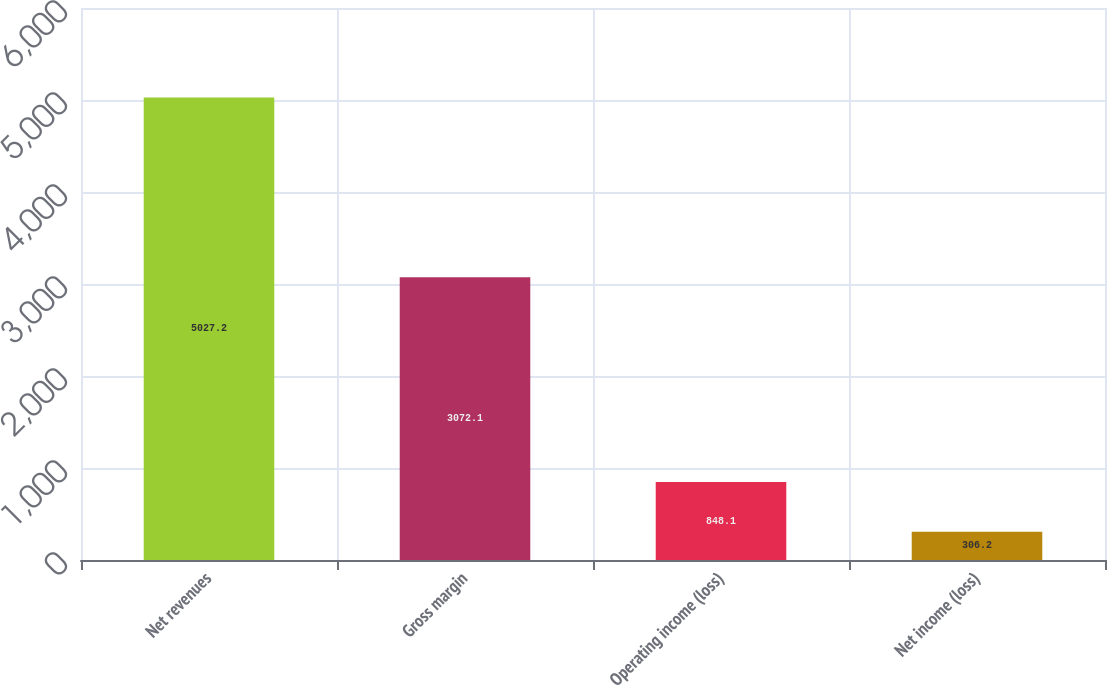Convert chart to OTSL. <chart><loc_0><loc_0><loc_500><loc_500><bar_chart><fcel>Net revenues<fcel>Gross margin<fcel>Operating income (loss)<fcel>Net income (loss)<nl><fcel>5027.2<fcel>3072.1<fcel>848.1<fcel>306.2<nl></chart> 